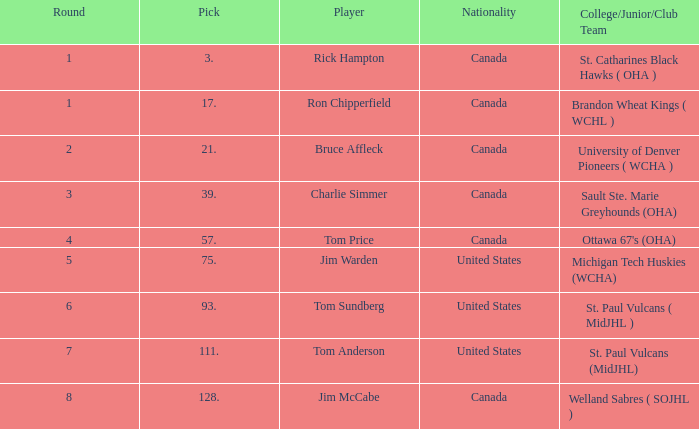Can you inform me of the nationality with a round less than 5, and the player of bruce affleck? Canada. 